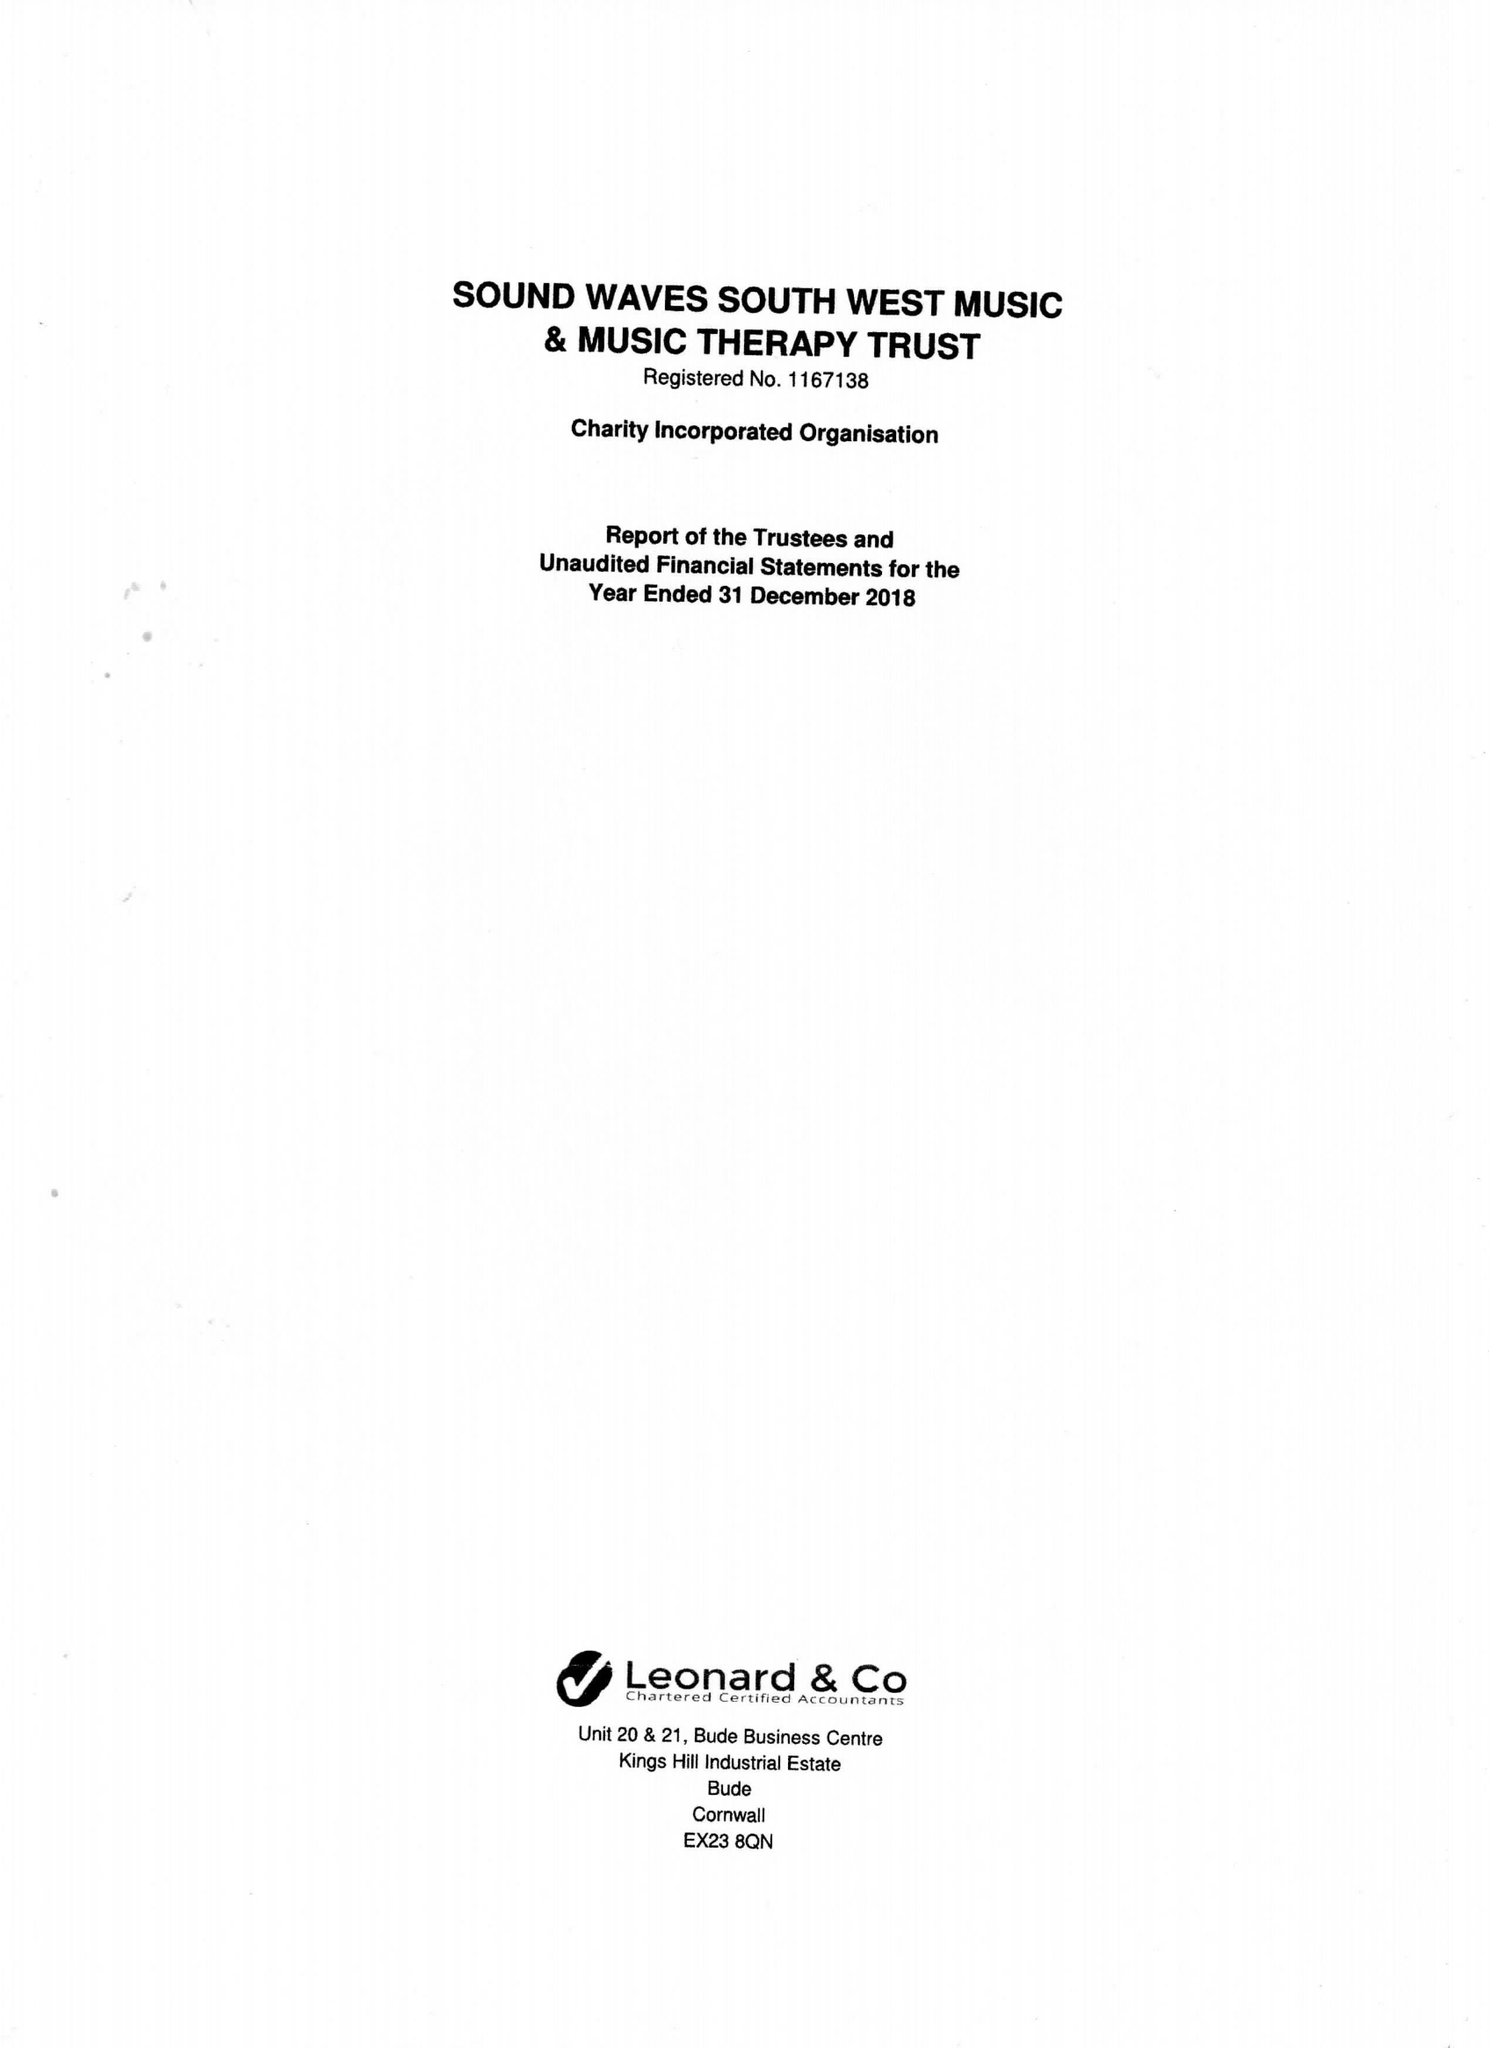What is the value for the address__post_town?
Answer the question using a single word or phrase. BUDE 